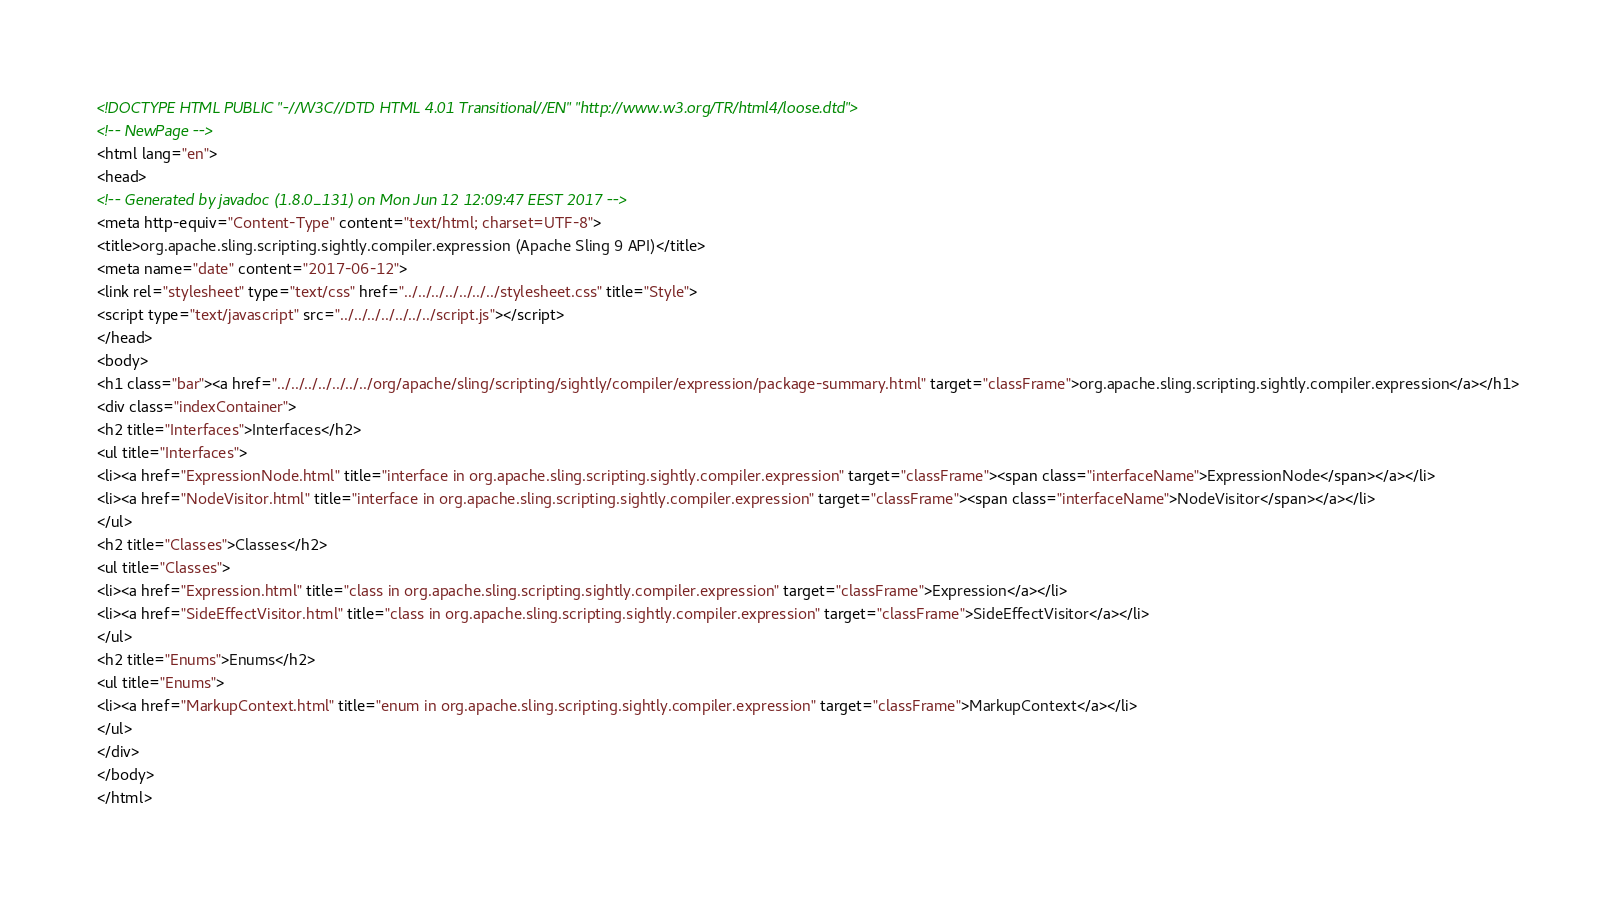<code> <loc_0><loc_0><loc_500><loc_500><_HTML_><!DOCTYPE HTML PUBLIC "-//W3C//DTD HTML 4.01 Transitional//EN" "http://www.w3.org/TR/html4/loose.dtd">
<!-- NewPage -->
<html lang="en">
<head>
<!-- Generated by javadoc (1.8.0_131) on Mon Jun 12 12:09:47 EEST 2017 -->
<meta http-equiv="Content-Type" content="text/html; charset=UTF-8">
<title>org.apache.sling.scripting.sightly.compiler.expression (Apache Sling 9 API)</title>
<meta name="date" content="2017-06-12">
<link rel="stylesheet" type="text/css" href="../../../../../../../stylesheet.css" title="Style">
<script type="text/javascript" src="../../../../../../../script.js"></script>
</head>
<body>
<h1 class="bar"><a href="../../../../../../../org/apache/sling/scripting/sightly/compiler/expression/package-summary.html" target="classFrame">org.apache.sling.scripting.sightly.compiler.expression</a></h1>
<div class="indexContainer">
<h2 title="Interfaces">Interfaces</h2>
<ul title="Interfaces">
<li><a href="ExpressionNode.html" title="interface in org.apache.sling.scripting.sightly.compiler.expression" target="classFrame"><span class="interfaceName">ExpressionNode</span></a></li>
<li><a href="NodeVisitor.html" title="interface in org.apache.sling.scripting.sightly.compiler.expression" target="classFrame"><span class="interfaceName">NodeVisitor</span></a></li>
</ul>
<h2 title="Classes">Classes</h2>
<ul title="Classes">
<li><a href="Expression.html" title="class in org.apache.sling.scripting.sightly.compiler.expression" target="classFrame">Expression</a></li>
<li><a href="SideEffectVisitor.html" title="class in org.apache.sling.scripting.sightly.compiler.expression" target="classFrame">SideEffectVisitor</a></li>
</ul>
<h2 title="Enums">Enums</h2>
<ul title="Enums">
<li><a href="MarkupContext.html" title="enum in org.apache.sling.scripting.sightly.compiler.expression" target="classFrame">MarkupContext</a></li>
</ul>
</div>
</body>
</html>
</code> 